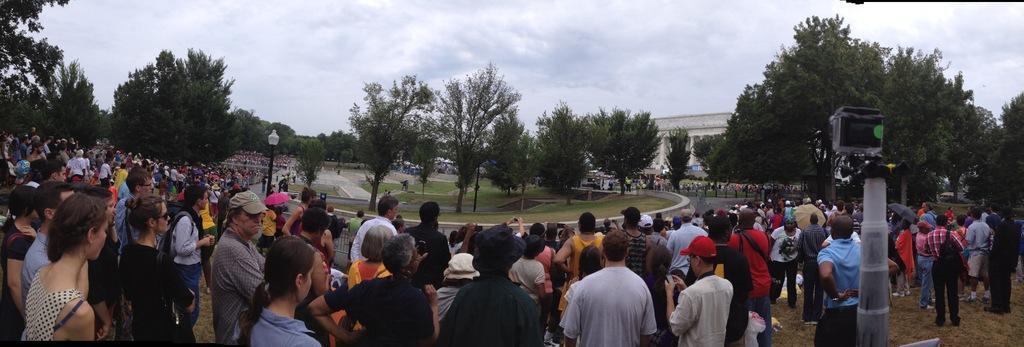Describe this image in one or two sentences. In this picture we can see a group of people standing on the ground, trees, poles, grass, building and some objects and in the background we can see the sky with clouds. 